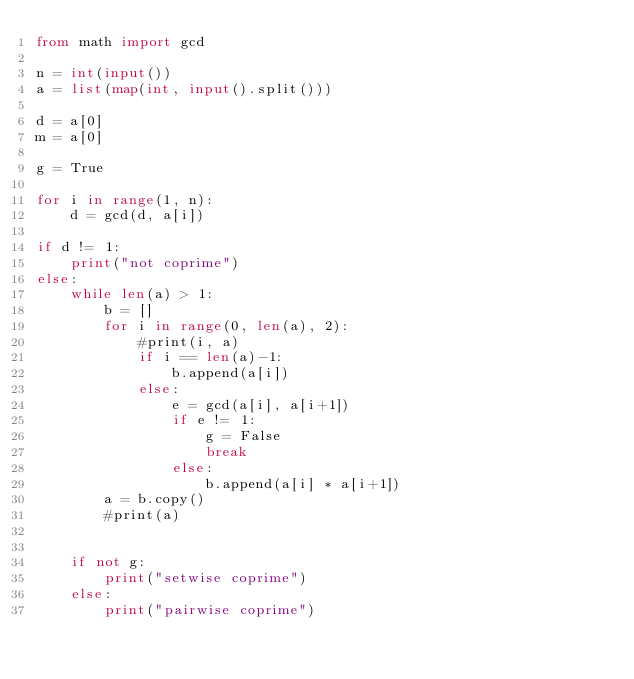Convert code to text. <code><loc_0><loc_0><loc_500><loc_500><_Python_>from math import gcd

n = int(input())
a = list(map(int, input().split()))

d = a[0]
m = a[0]

g = True

for i in range(1, n):
    d = gcd(d, a[i])

if d != 1:
    print("not coprime")
else:
    while len(a) > 1:
        b = []
        for i in range(0, len(a), 2):
            #print(i, a)
            if i == len(a)-1:
                b.append(a[i])
            else:
                e = gcd(a[i], a[i+1])
                if e != 1:
                    g = False
                    break
                else:
                    b.append(a[i] * a[i+1])
        a = b.copy()
        #print(a)


    if not g:
        print("setwise coprime")
    else:
        print("pairwise coprime")</code> 